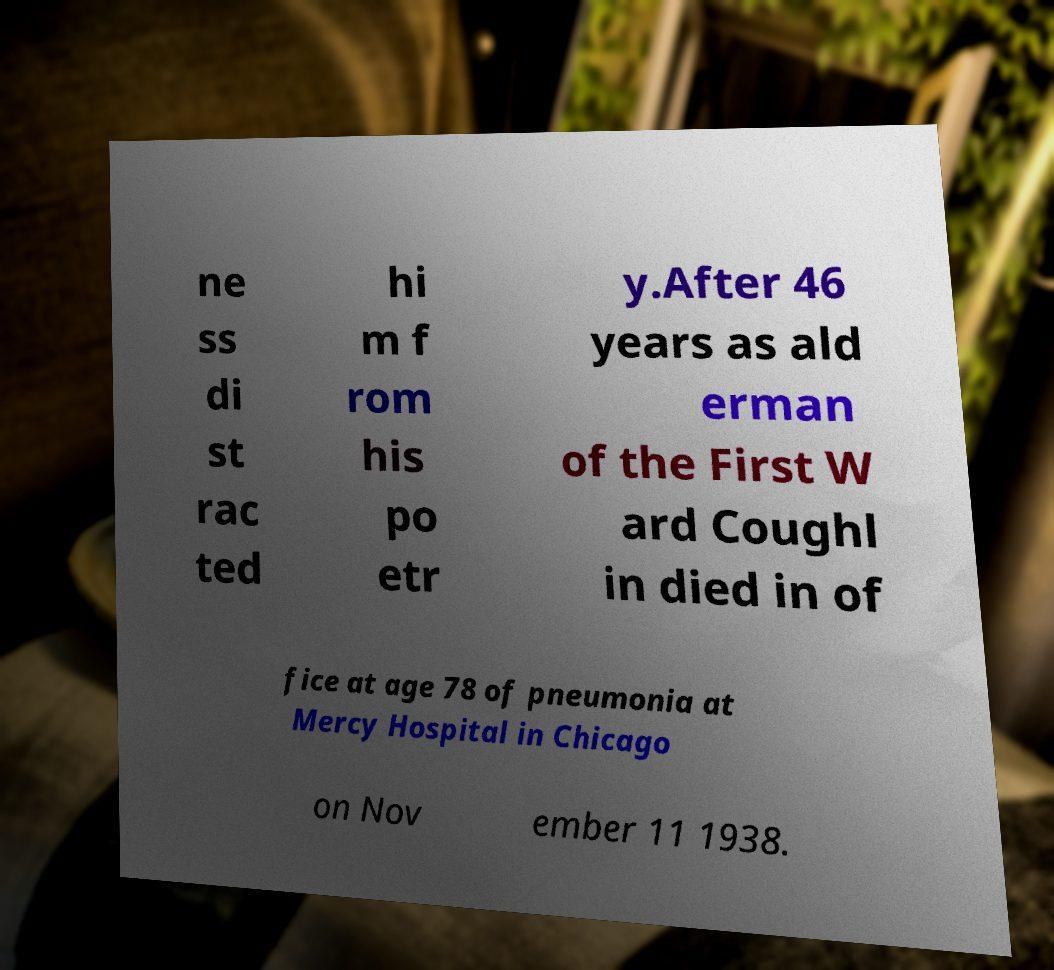Please read and relay the text visible in this image. What does it say? ne ss di st rac ted hi m f rom his po etr y.After 46 years as ald erman of the First W ard Coughl in died in of fice at age 78 of pneumonia at Mercy Hospital in Chicago on Nov ember 11 1938. 